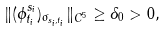<formula> <loc_0><loc_0><loc_500><loc_500>\| ( \phi ^ { s _ { i } } _ { t _ { i } } ) _ { \sigma _ { s _ { i } , t _ { i } } } \| _ { C ^ { 5 } } \geq \delta _ { 0 } > 0 ,</formula> 